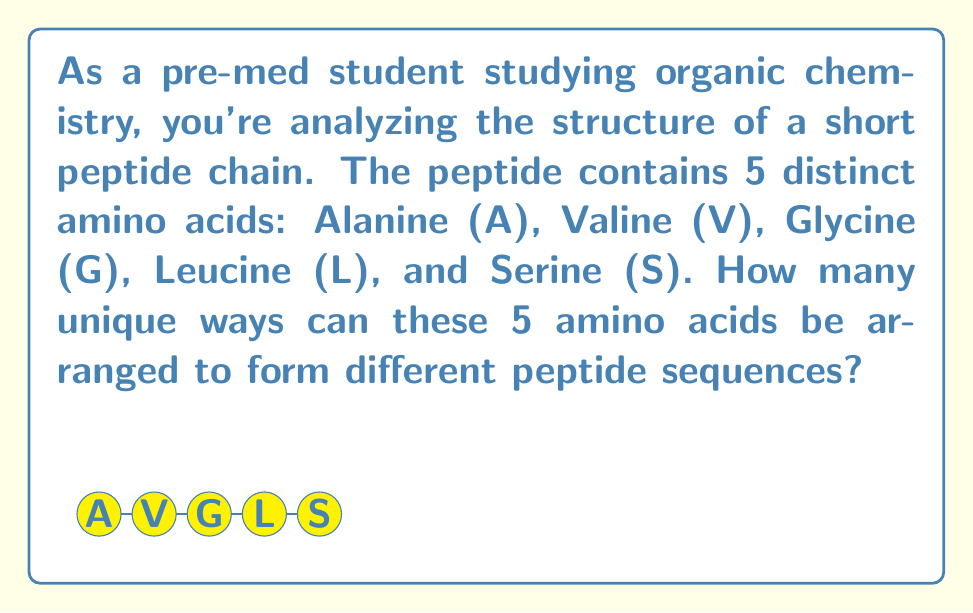Teach me how to tackle this problem. Let's approach this step-by-step:

1) We have 5 distinct amino acids, and we want to arrange all of them in a sequence.

2) This is a permutation problem, as the order matters in a peptide sequence.

3) The number of permutations of n distinct objects is given by the formula:

   $$P(n) = n!$$

   Where $n!$ represents the factorial of $n$.

4) In this case, $n = 5$ (as we have 5 distinct amino acids).

5) Therefore, the number of unique arrangements is:

   $$P(5) = 5!$$

6) Let's calculate 5!:
   
   $$5! = 5 \times 4 \times 3 \times 2 \times 1 = 120$$

Thus, there are 120 unique ways to arrange these 5 amino acids in a peptide chain.
Answer: $120$ 